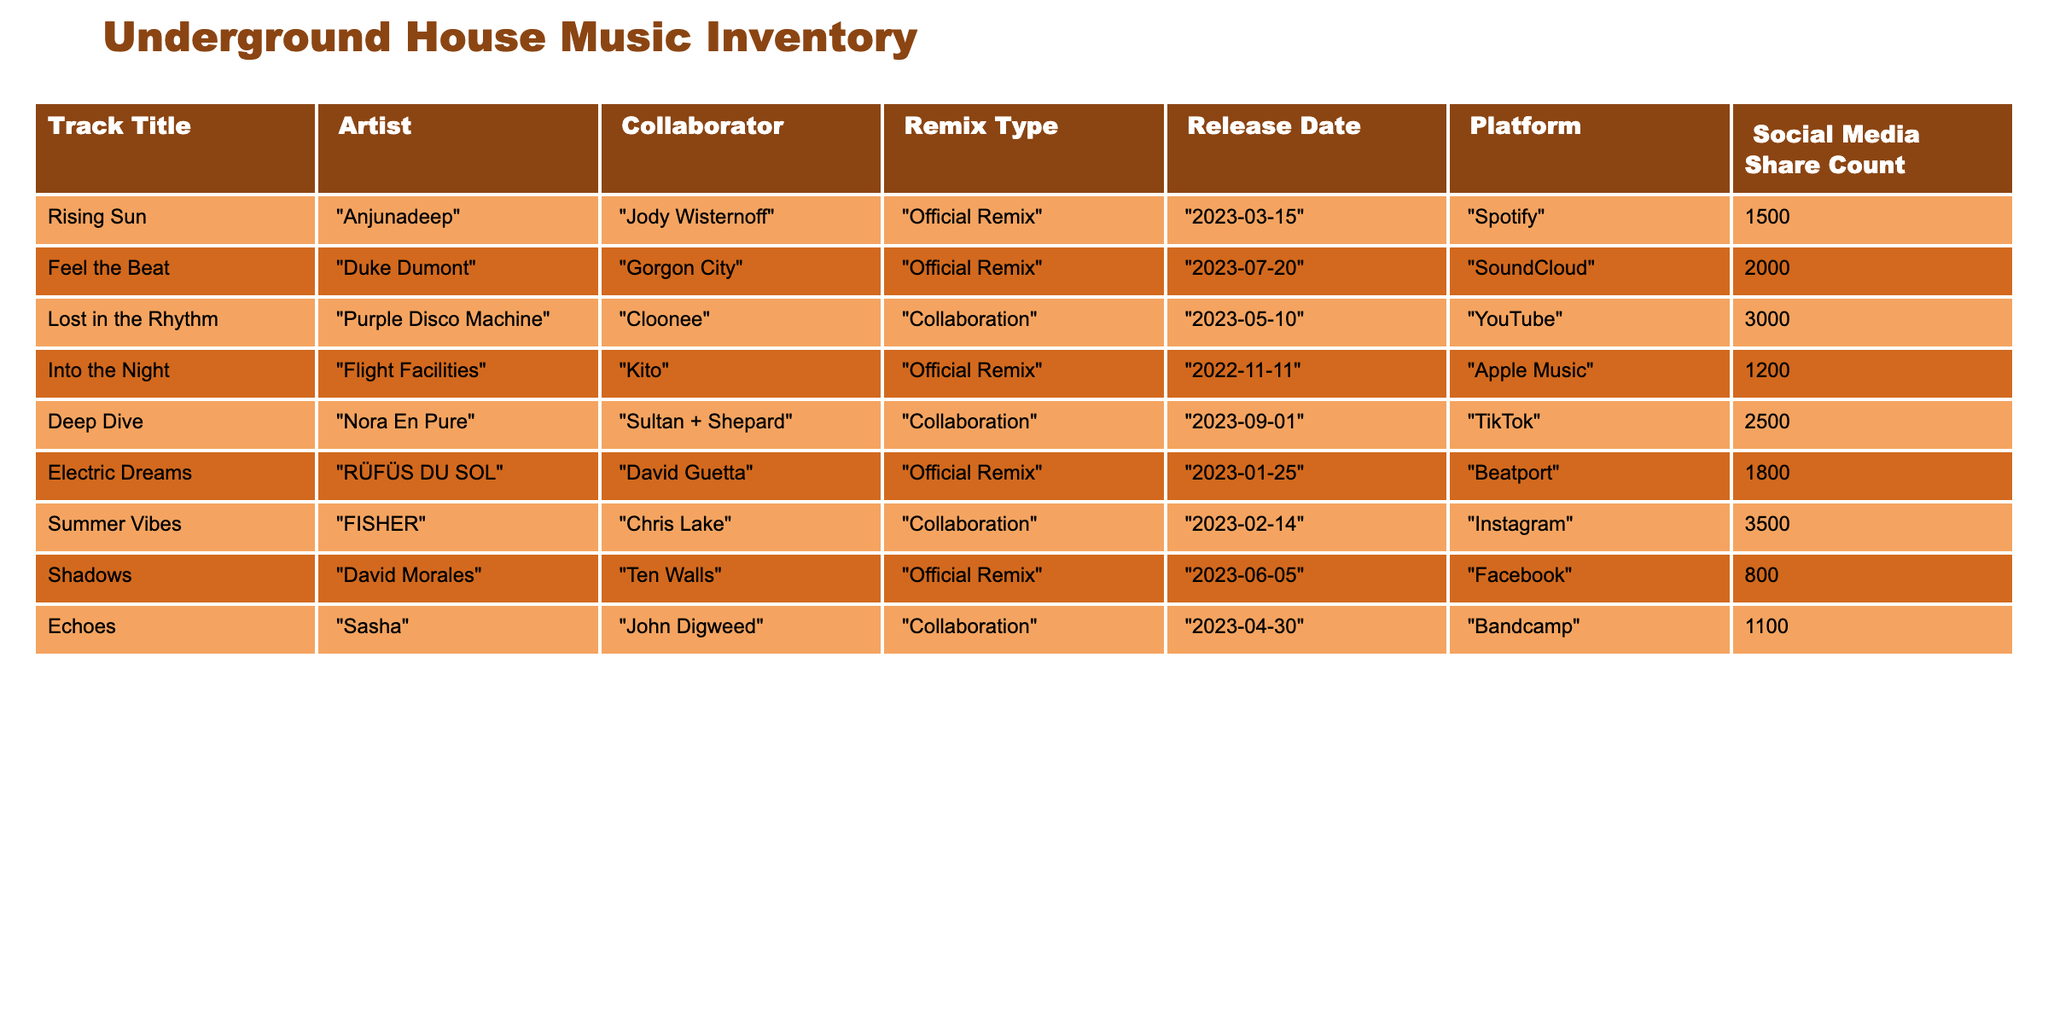What is the release date of "Deep Dive"? "Deep Dive" is listed in the table with a release date of "2023-09-01". You can find this information directly in the corresponding row for "Deep Dive".
Answer: 2023-09-01 Who collaborated with "Purple Disco Machine" on "Lost in the Rhythm"? The table indicates that "Cloonee" collaborated with "Purple Disco Machine" on the track "Lost in the Rhythm". This information is readily available in the row for that track.
Answer: Cloonee How many social media shares does the track "Feel the Beat" have? The table shows that "Feel the Beat" has a social media share count of 2000. This can be found directly by looking at the row for "Feel the Beat".
Answer: 2000 Which artist had the highest social media shares? To find the artist with the highest social media shares, you can compare the share counts for all artists. "Summer Vibes" by "FISHER" has the highest count at 3500 shares. Therefore, FISHER is the artist with the most shares.
Answer: FISHER What is the difference in social media shares between "Electric Dreams" and "Shadows"? "Electric Dreams" has 1800 shares, and "Shadows" has 800 shares. The difference can be calculated as 1800 - 800 = 1000. Thus, the difference in shares is 1000.
Answer: 1000 Are there any collaborations that were released in 2023? By examining the table, we can see that "Lost in the Rhythm", "Deep Dive", "Summer Vibes", and "Electric Dreams" were all released in 2023, indicating that there are indeed collaborations from that year.
Answer: Yes Which track has the lowest share count and what is the artist's name? Looking at the social media shares, "Shadows" has the lowest count at 800. The artist associated with that track is "David Morales". This information can be easily found by identifying the minimum share count.
Answer: David Morales What is the average number of social media shares for the collaborations listed in the table? First, we need to identify the social media shares for the collaborations: "Lost in the Rhythm" (3000), "Deep Dive" (2500), "Summer Vibes" (3500), and "Echoes" (1100). Adding these gives a total of 10100. There are 4 collaborations, so the average is 10100 / 4 = 2525.
Answer: 2525 How many official remixes are listed in the table? The table has three entries labeled as "Official Remix": "Rising Sun", "Into the Night", and "Electric Dreams". Counting these entries gives us a total of 3 official remixes.
Answer: 3 